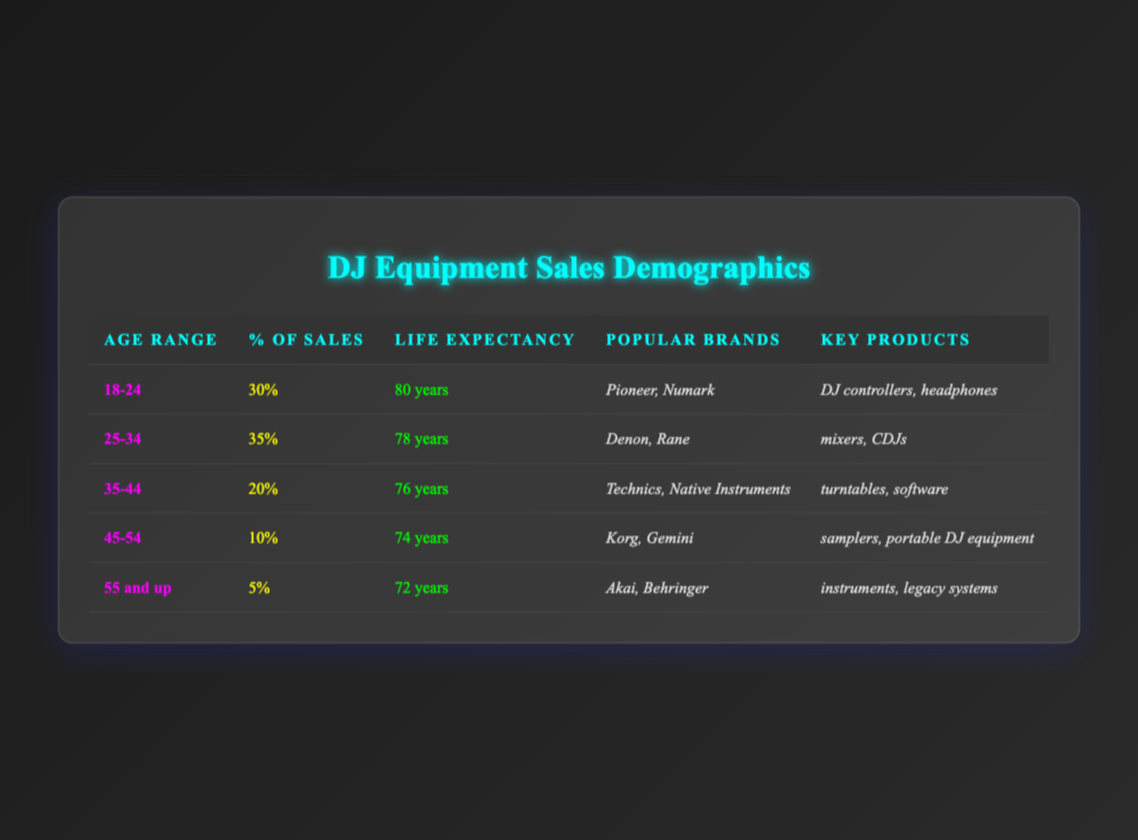What percentage of DJ equipment sales comes from the age group 25-34? From the table, the percentage of sales for the age group 25-34 is listed directly in that row as 35%.
Answer: 35% Which age group has the highest life expectancy? The age group with the highest life expectancy is 18-24, with an average life expectancy of 80 years, as seen in the corresponding row of the table.
Answer: 18-24 How many years younger is the life expectancy of the 45-54 age group compared to the 18-24 age group? The life expectancy of the 45-54 age group is 74 years, while the 18-24 age group's life expectancy is 80 years. The difference is 80 - 74 = 6 years.
Answer: 6 years What are the popular brands for the 35-44 age group? According to the table, the popular brands for the 35-44 age group are Technics and Native Instruments, as listed in the relevant row of the table.
Answer: Technics, Native Instruments Is it true that the age group 55 and up contributes more than 10% to DJ equipment sales? No, the table shows that the 55 and up age group only contributes 5% to DJ equipment sales, which is less than 10%.
Answer: No What is the combined percentage of DJ equipment sales from the age groups 45-54 and 55 and up? The percentage of sales for the 45-54 age group is 10%, and for the 55 and up age group, it is 5%. Combined, they make 10 + 5 = 15%.
Answer: 15% Which key products are notable in the 25-34 age group? The key products listed for the 25-34 age group include mixers and CDJs, found directly in the corresponding row of the table.
Answer: Mixers, CDJs Which age group has both the lowest life expectancy and lowest percentage of sales? The age group 55 and up has the lowest life expectancy at 72 years and also the lowest percentage of sales at 5%, as indicated by the table.
Answer: 55 and up What is the average life expectancy of all age groups? To calculate the average, we sum the life expectancies: (80 + 78 + 76 + 74 + 72) = 380 years. There are 5 age groups, so the average life expectancy is 380 / 5 = 76 years.
Answer: 76 years 